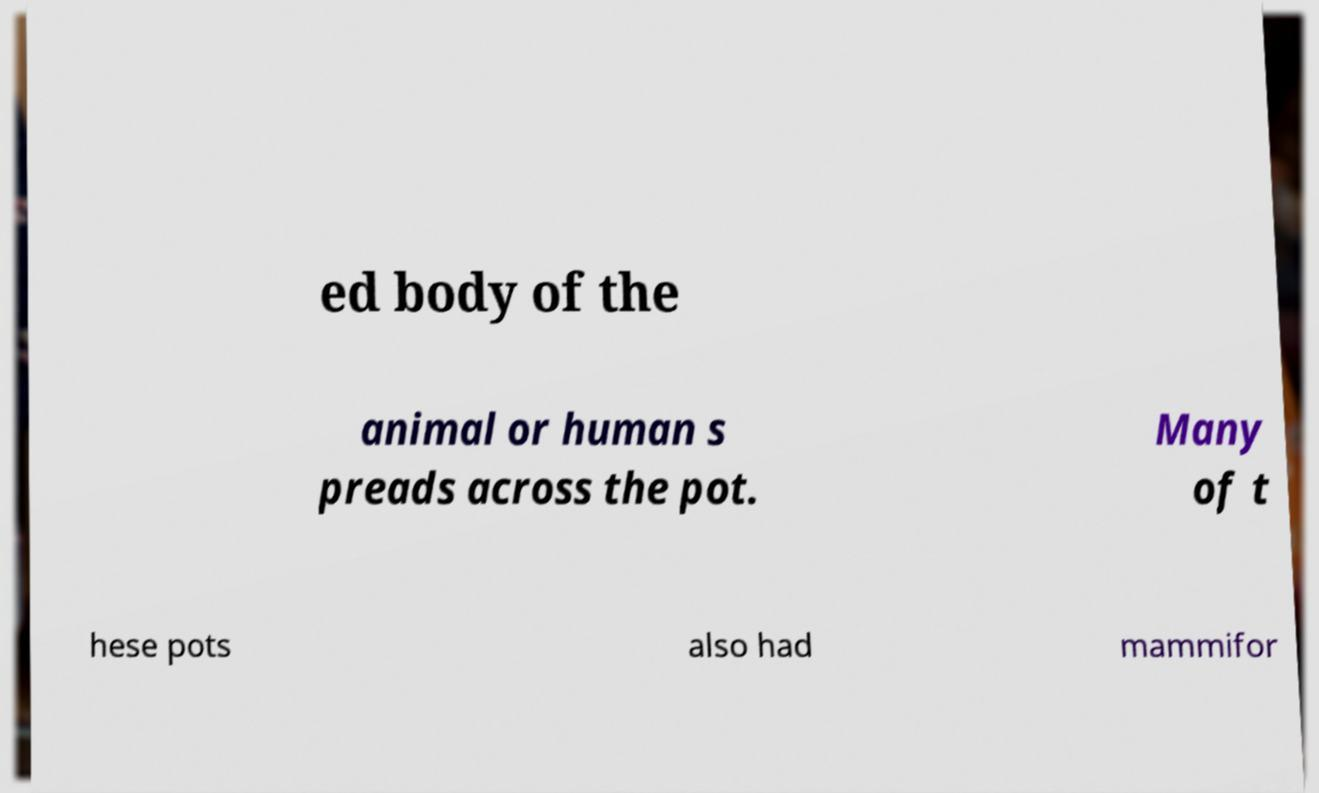Can you read and provide the text displayed in the image?This photo seems to have some interesting text. Can you extract and type it out for me? ed body of the animal or human s preads across the pot. Many of t hese pots also had mammifor 